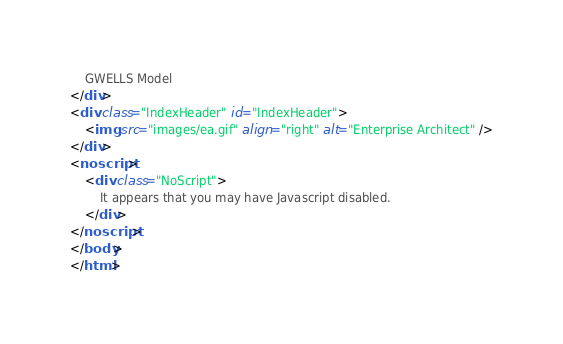Convert code to text. <code><loc_0><loc_0><loc_500><loc_500><_HTML_>	GWELLS Model
</div>
<div class="IndexHeader" id="IndexHeader">
	<img src="images/ea.gif" align="right" alt="Enterprise Architect" />
</div>
<noscript>
	<div class="NoScript">
		It appears that you may have Javascript disabled.
	</div>
</noscript>
</body>
</html></code> 